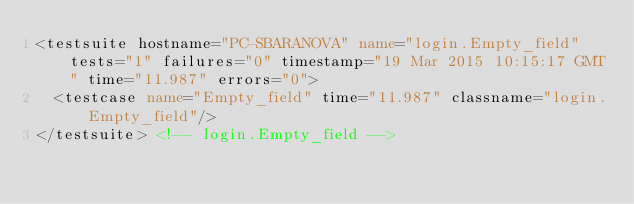Convert code to text. <code><loc_0><loc_0><loc_500><loc_500><_XML_><testsuite hostname="PC-SBARANOVA" name="login.Empty_field" tests="1" failures="0" timestamp="19 Mar 2015 10:15:17 GMT" time="11.987" errors="0">
  <testcase name="Empty_field" time="11.987" classname="login.Empty_field"/>
</testsuite> <!-- login.Empty_field -->
</code> 